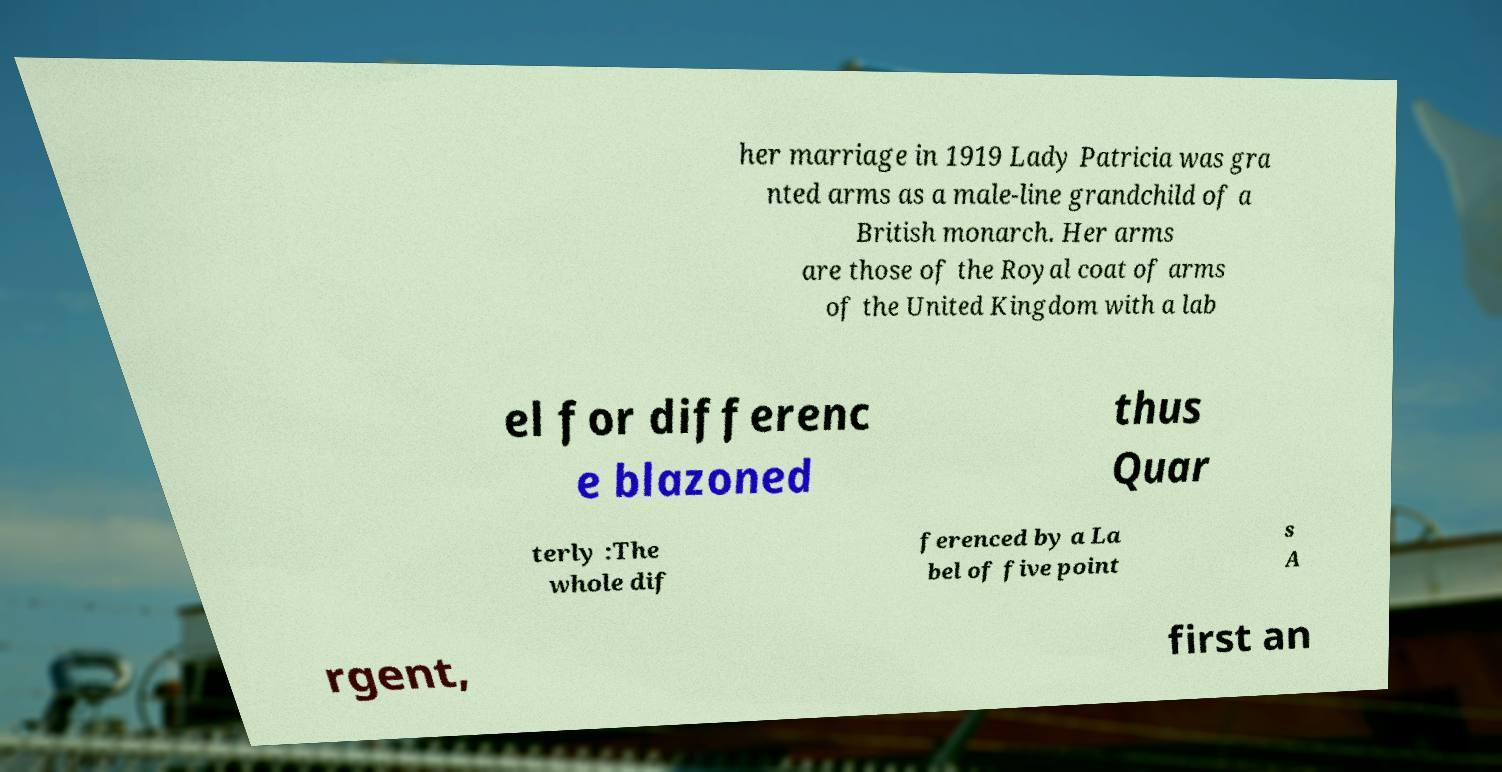Can you read and provide the text displayed in the image?This photo seems to have some interesting text. Can you extract and type it out for me? her marriage in 1919 Lady Patricia was gra nted arms as a male-line grandchild of a British monarch. Her arms are those of the Royal coat of arms of the United Kingdom with a lab el for differenc e blazoned thus Quar terly :The whole dif ferenced by a La bel of five point s A rgent, first an 